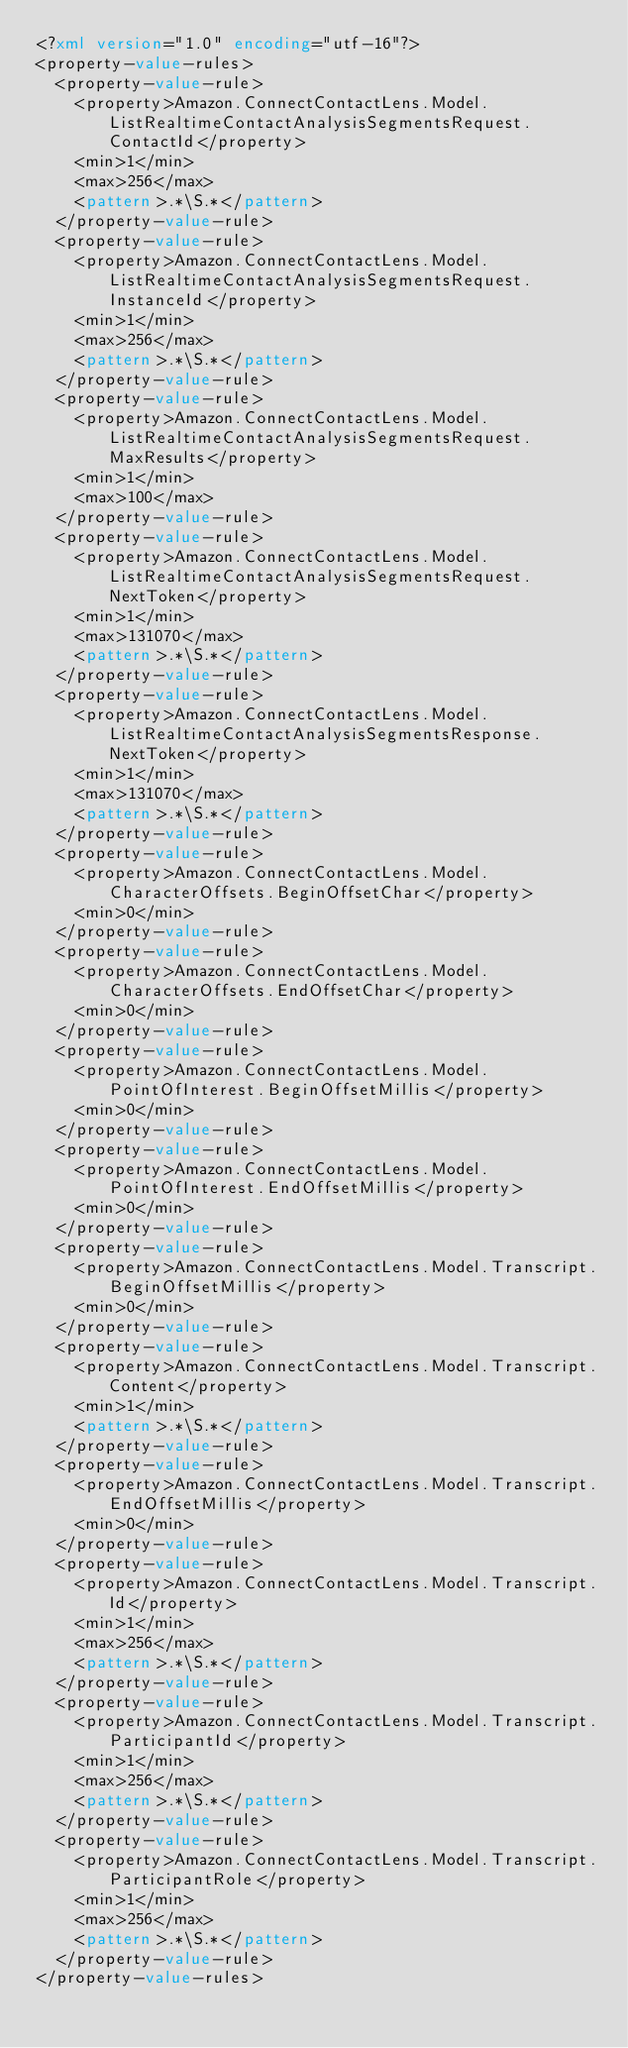<code> <loc_0><loc_0><loc_500><loc_500><_XML_><?xml version="1.0" encoding="utf-16"?>
<property-value-rules>
  <property-value-rule>
    <property>Amazon.ConnectContactLens.Model.ListRealtimeContactAnalysisSegmentsRequest.ContactId</property>
    <min>1</min>
    <max>256</max>
    <pattern>.*\S.*</pattern>
  </property-value-rule>
  <property-value-rule>
    <property>Amazon.ConnectContactLens.Model.ListRealtimeContactAnalysisSegmentsRequest.InstanceId</property>
    <min>1</min>
    <max>256</max>
    <pattern>.*\S.*</pattern>
  </property-value-rule>
  <property-value-rule>
    <property>Amazon.ConnectContactLens.Model.ListRealtimeContactAnalysisSegmentsRequest.MaxResults</property>
    <min>1</min>
    <max>100</max>
  </property-value-rule>
  <property-value-rule>
    <property>Amazon.ConnectContactLens.Model.ListRealtimeContactAnalysisSegmentsRequest.NextToken</property>
    <min>1</min>
    <max>131070</max>
    <pattern>.*\S.*</pattern>
  </property-value-rule>
  <property-value-rule>
    <property>Amazon.ConnectContactLens.Model.ListRealtimeContactAnalysisSegmentsResponse.NextToken</property>
    <min>1</min>
    <max>131070</max>
    <pattern>.*\S.*</pattern>
  </property-value-rule>
  <property-value-rule>
    <property>Amazon.ConnectContactLens.Model.CharacterOffsets.BeginOffsetChar</property>
    <min>0</min>
  </property-value-rule>
  <property-value-rule>
    <property>Amazon.ConnectContactLens.Model.CharacterOffsets.EndOffsetChar</property>
    <min>0</min>
  </property-value-rule>
  <property-value-rule>
    <property>Amazon.ConnectContactLens.Model.PointOfInterest.BeginOffsetMillis</property>
    <min>0</min>
  </property-value-rule>
  <property-value-rule>
    <property>Amazon.ConnectContactLens.Model.PointOfInterest.EndOffsetMillis</property>
    <min>0</min>
  </property-value-rule>
  <property-value-rule>
    <property>Amazon.ConnectContactLens.Model.Transcript.BeginOffsetMillis</property>
    <min>0</min>
  </property-value-rule>
  <property-value-rule>
    <property>Amazon.ConnectContactLens.Model.Transcript.Content</property>
    <min>1</min>
    <pattern>.*\S.*</pattern>
  </property-value-rule>
  <property-value-rule>
    <property>Amazon.ConnectContactLens.Model.Transcript.EndOffsetMillis</property>
    <min>0</min>
  </property-value-rule>
  <property-value-rule>
    <property>Amazon.ConnectContactLens.Model.Transcript.Id</property>
    <min>1</min>
    <max>256</max>
    <pattern>.*\S.*</pattern>
  </property-value-rule>
  <property-value-rule>
    <property>Amazon.ConnectContactLens.Model.Transcript.ParticipantId</property>
    <min>1</min>
    <max>256</max>
    <pattern>.*\S.*</pattern>
  </property-value-rule>
  <property-value-rule>
    <property>Amazon.ConnectContactLens.Model.Transcript.ParticipantRole</property>
    <min>1</min>
    <max>256</max>
    <pattern>.*\S.*</pattern>
  </property-value-rule>
</property-value-rules></code> 